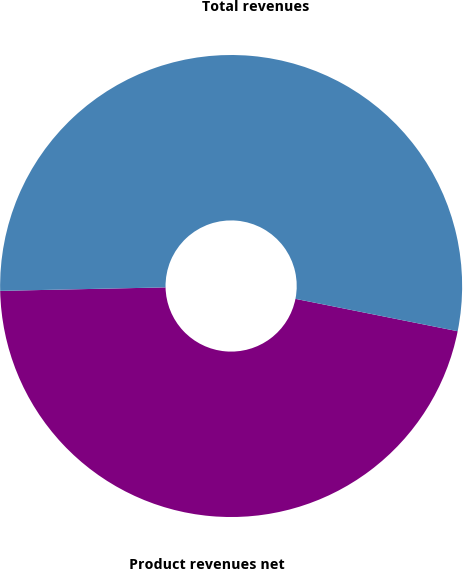<chart> <loc_0><loc_0><loc_500><loc_500><pie_chart><fcel>Product revenues net<fcel>Total revenues<nl><fcel>46.53%<fcel>53.47%<nl></chart> 